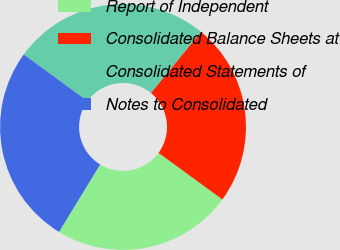Convert chart. <chart><loc_0><loc_0><loc_500><loc_500><pie_chart><fcel>Report of Independent<fcel>Consolidated Balance Sheets at<fcel>Consolidated Statements of<fcel>Notes to Consolidated<nl><fcel>23.68%<fcel>24.12%<fcel>25.88%<fcel>26.32%<nl></chart> 